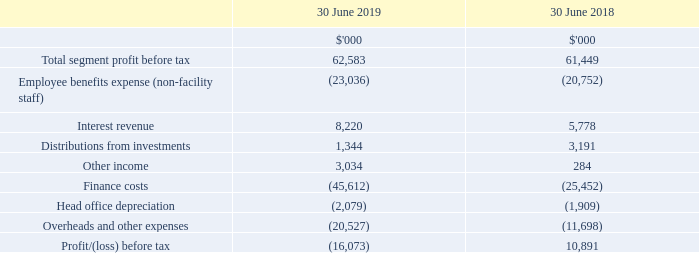1 Segment performance (continued)
(c) Other segment information
(i) Profit/(loss) before tax
Management assesses the performance of the operating segments based on a measure of EBITDA. Interest income and expenditure are not allocated to segments, as this type of activity is driven by the central treasury function, which manages the cash position of the Group. On adoption of AASB 16 from 1 July 2018, associated lease interest is allocated to the respective segments as a finance charge.
How do NextDC Management assess performance of the operating segments? Based on a measure of ebitda. What was the change in accounting for leases introduced by new adopted accounting standard AASB 16? Associated lease interest is allocated to the respective segments as a finance charge. What was the total segment profit before tax in FY18?
Answer scale should be: thousand. 61,449. What was the total expenses in FY2019?
Answer scale should be: thousand. 23,036 + 45,612 + 2,079 + 20,527 
Answer: 91254. Which year(s) incurred a loss before tax? Profit/(loss) before tax = (16,073)
Answer: 2019. What was the percentage change in finance costs between 2018 and 2019?
Answer scale should be: percent. (45,612 - 25,452) / 25,452 
Answer: 79.21. 